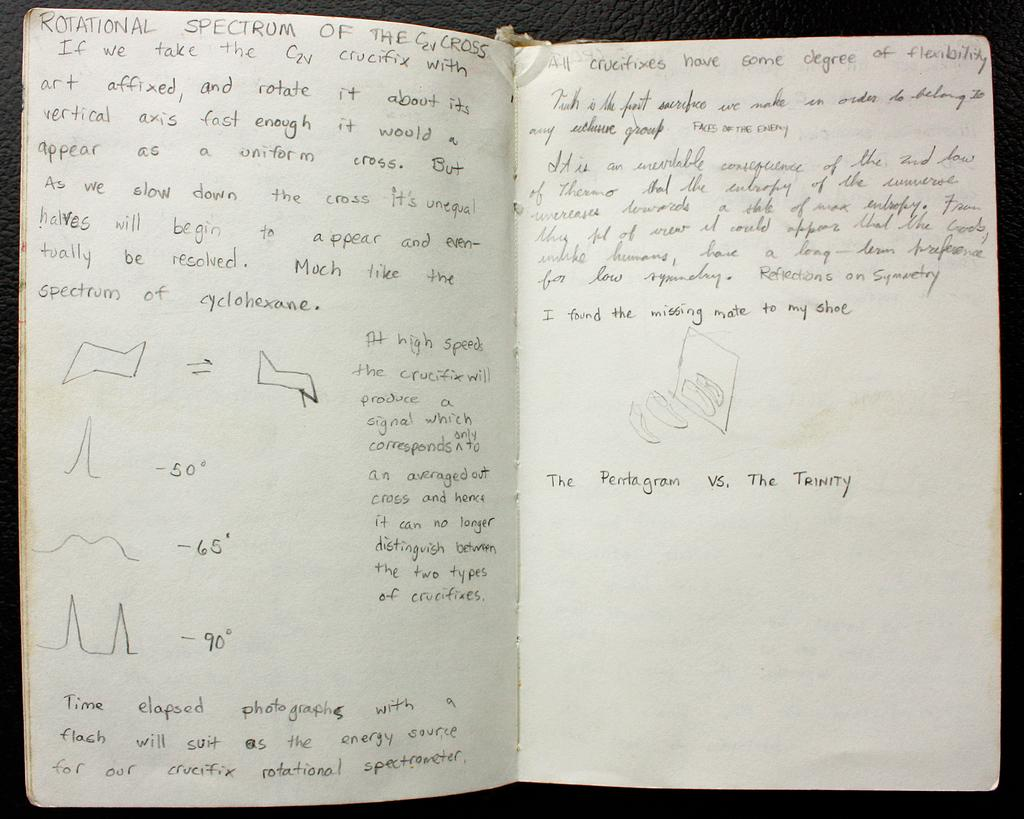Provide a one-sentence caption for the provided image. A notebook opened to show notes related to the rotational spectrum of a cross. 